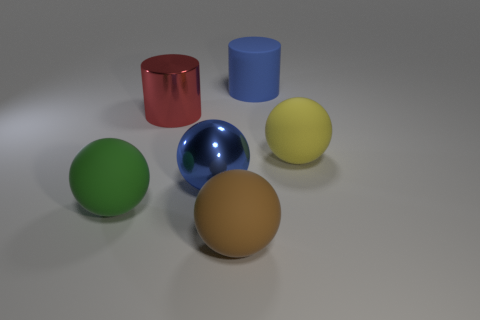Add 3 green objects. How many objects exist? 9 Subtract all balls. How many objects are left? 2 Add 2 tiny shiny spheres. How many tiny shiny spheres exist? 2 Subtract 0 yellow cylinders. How many objects are left? 6 Subtract all red cylinders. Subtract all brown objects. How many objects are left? 4 Add 5 red things. How many red things are left? 6 